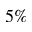<formula> <loc_0><loc_0><loc_500><loc_500>5 \%</formula> 